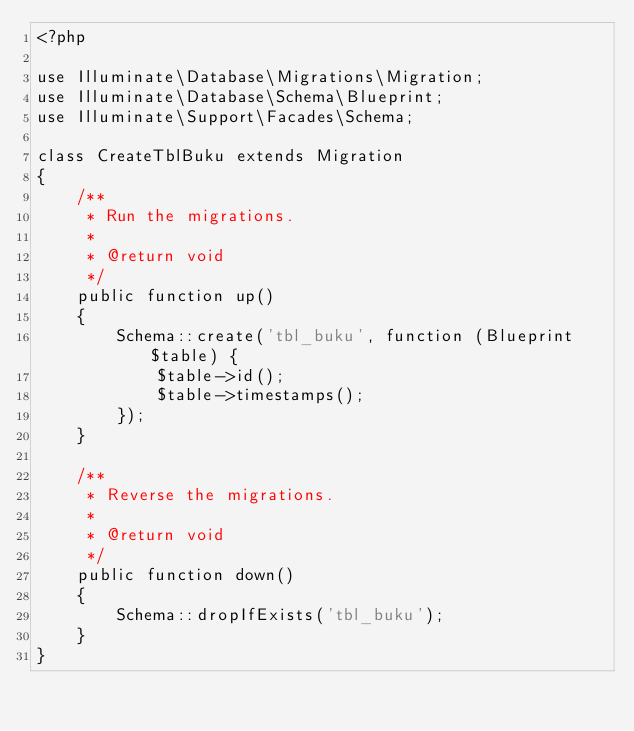<code> <loc_0><loc_0><loc_500><loc_500><_PHP_><?php

use Illuminate\Database\Migrations\Migration;
use Illuminate\Database\Schema\Blueprint;
use Illuminate\Support\Facades\Schema;

class CreateTblBuku extends Migration
{
    /**
     * Run the migrations.
     *
     * @return void
     */
    public function up()
    {
        Schema::create('tbl_buku', function (Blueprint $table) {
            $table->id();
            $table->timestamps();
        });
    }

    /**
     * Reverse the migrations.
     *
     * @return void
     */
    public function down()
    {
        Schema::dropIfExists('tbl_buku');
    }
}
</code> 